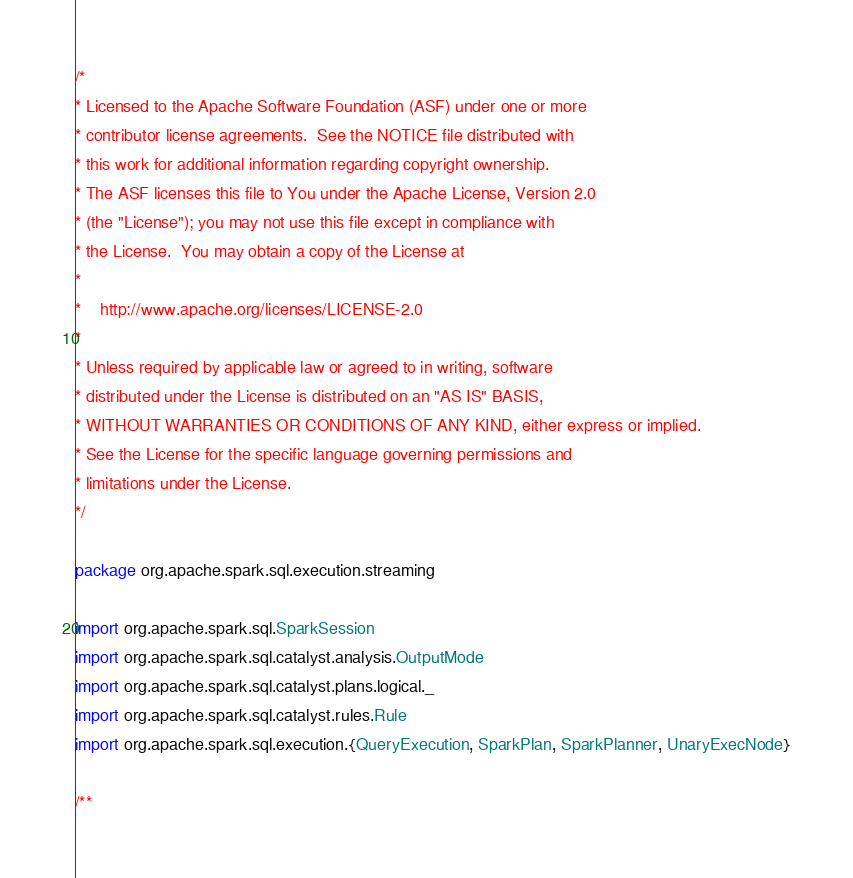<code> <loc_0><loc_0><loc_500><loc_500><_Scala_>/*
* Licensed to the Apache Software Foundation (ASF) under one or more
* contributor license agreements.  See the NOTICE file distributed with
* this work for additional information regarding copyright ownership.
* The ASF licenses this file to You under the Apache License, Version 2.0
* (the "License"); you may not use this file except in compliance with
* the License.  You may obtain a copy of the License at
*
*    http://www.apache.org/licenses/LICENSE-2.0
*
* Unless required by applicable law or agreed to in writing, software
* distributed under the License is distributed on an "AS IS" BASIS,
* WITHOUT WARRANTIES OR CONDITIONS OF ANY KIND, either express or implied.
* See the License for the specific language governing permissions and
* limitations under the License.
*/

package org.apache.spark.sql.execution.streaming

import org.apache.spark.sql.SparkSession
import org.apache.spark.sql.catalyst.analysis.OutputMode
import org.apache.spark.sql.catalyst.plans.logical._
import org.apache.spark.sql.catalyst.rules.Rule
import org.apache.spark.sql.execution.{QueryExecution, SparkPlan, SparkPlanner, UnaryExecNode}

/**</code> 